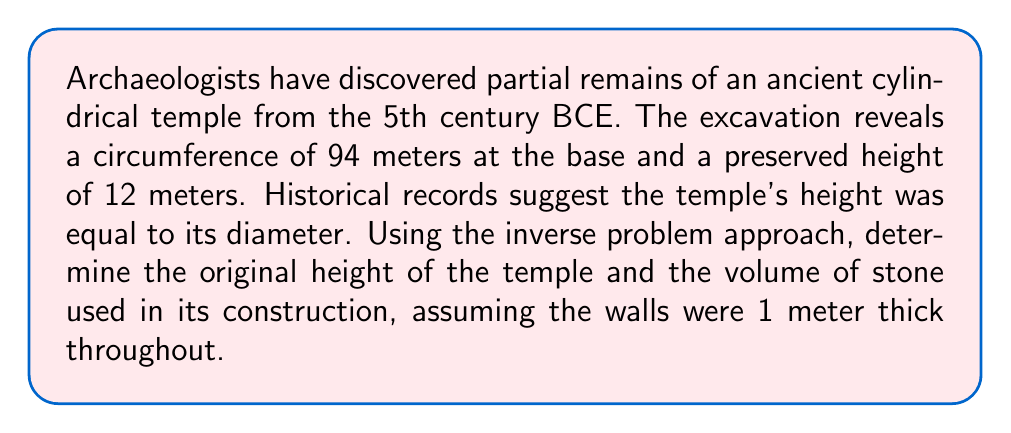Teach me how to tackle this problem. 1. Calculate the diameter of the temple:
   Circumference = $\pi d$
   $94 = \pi d$
   $d = \frac{94}{\pi} \approx 29.92$ meters

2. Since the height was equal to the diameter, the original height was also 29.92 meters.

3. Calculate the volume of the cylindrical structure:
   Outer volume: $V_o = \pi r_o^2 h$
   Inner volume: $V_i = \pi r_i^2 h$
   
   Where:
   $r_o = \frac{d}{2} = 14.96$ meters
   $r_i = r_o - 1 = 13.96$ meters (accounting for 1-meter thick walls)
   $h = 29.92$ meters

4. Calculate the volume of stone used:
   $V_{stone} = V_o - V_i$
   $V_{stone} = \pi (14.96^2 - 13.96^2) \cdot 29.92$
   $V_{stone} = \pi (223.8016 - 194.8816) \cdot 29.92$
   $V_{stone} = \pi \cdot 28.92 \cdot 29.92$
   $V_{stone} \approx 2,713.76$ cubic meters
Answer: Original height: 29.92 m; Stone volume: 2,713.76 m³ 